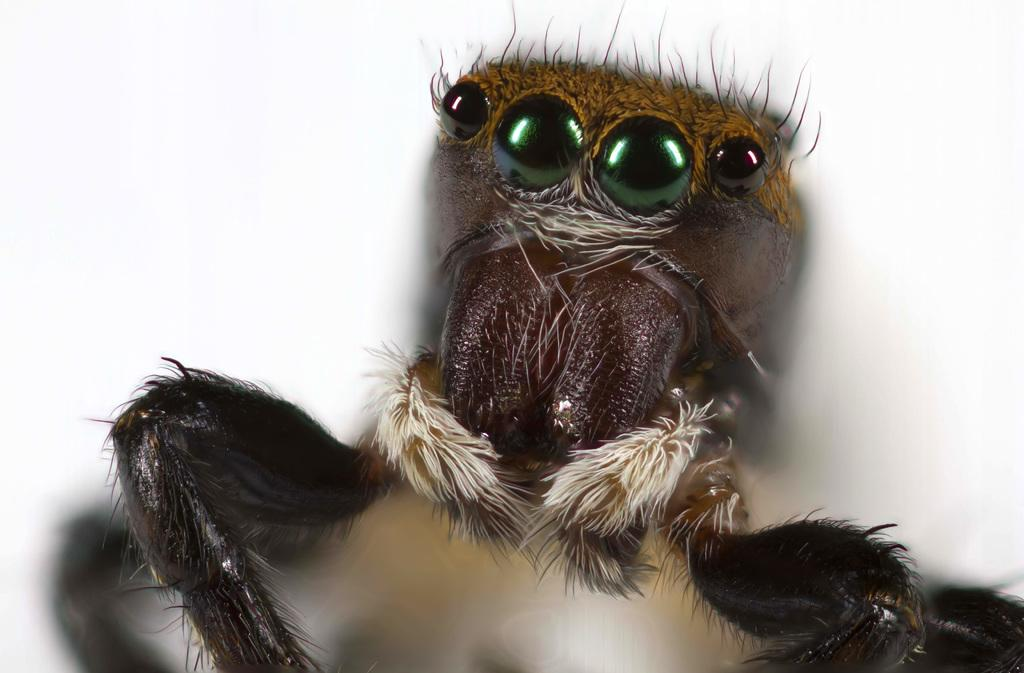What type of creature can be seen in the image? There is an insect in the picture. What color is the background of the image? The background of the image is white. What type of legal advice can be obtained from the insect in the image? There is no lawyer or legal advice present in the image, as it features an insect and a white background. 